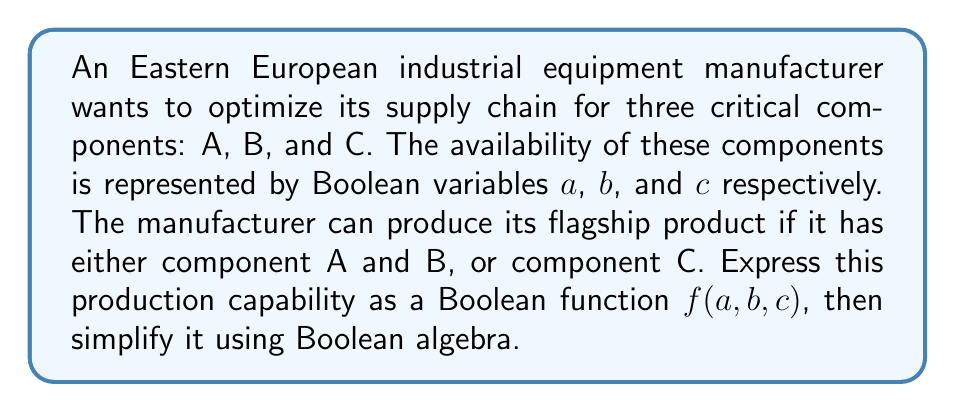Can you answer this question? 1) First, let's express the production capability as a Boolean function:
   $f(a,b,c) = (a \wedge b) \vee c$

2) To simplify this function, we can use the distributive law of Boolean algebra:
   $(x \wedge y) \vee z = (x \vee z) \wedge (y \vee z)$

3) Applying this to our function:
   $f(a,b,c) = (a \wedge b) \vee c = (a \vee c) \wedge (b \vee c)$

4) This simplified form represents the same production capability but can be more efficient for supply chain optimization. It shows that production is possible if:
   - Either component A or C is available, AND
   - Either component B or C is available

5) This form allows for more flexible inventory management. For instance, having component C in stock can compensate for a lack of either A or B, potentially reducing storage costs and improving supply chain resilience.

6) In the context of Eastern European industrial dynamics, this optimization could be particularly valuable due to potential supply chain disruptions or variations in component availability from different regional suppliers.
Answer: $f(a,b,c) = (a \vee c) \wedge (b \vee c)$ 